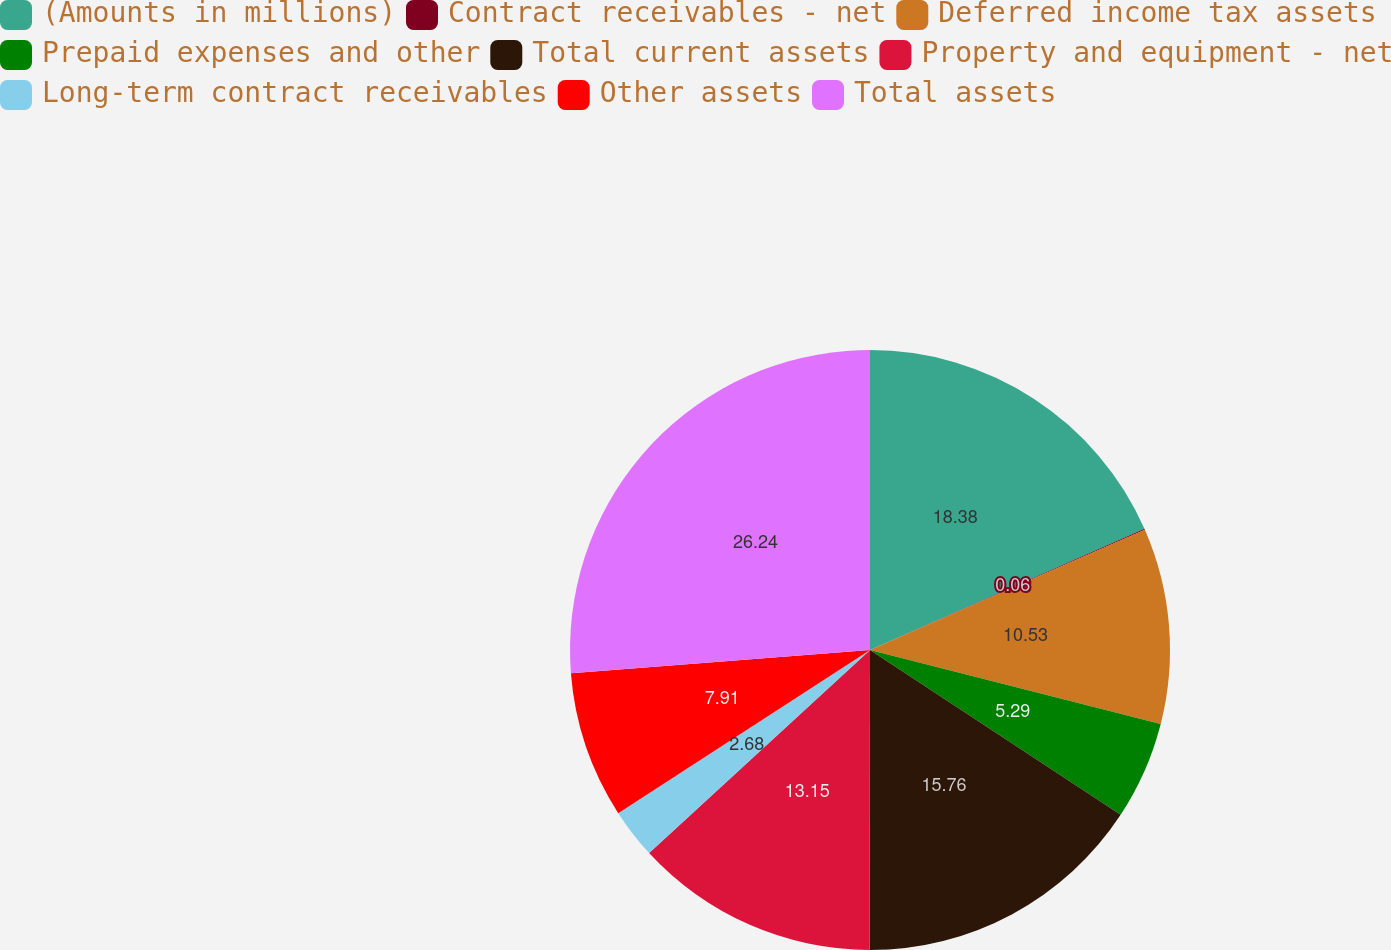Convert chart. <chart><loc_0><loc_0><loc_500><loc_500><pie_chart><fcel>(Amounts in millions)<fcel>Contract receivables - net<fcel>Deferred income tax assets<fcel>Prepaid expenses and other<fcel>Total current assets<fcel>Property and equipment - net<fcel>Long-term contract receivables<fcel>Other assets<fcel>Total assets<nl><fcel>18.38%<fcel>0.06%<fcel>10.53%<fcel>5.29%<fcel>15.76%<fcel>13.15%<fcel>2.68%<fcel>7.91%<fcel>26.24%<nl></chart> 